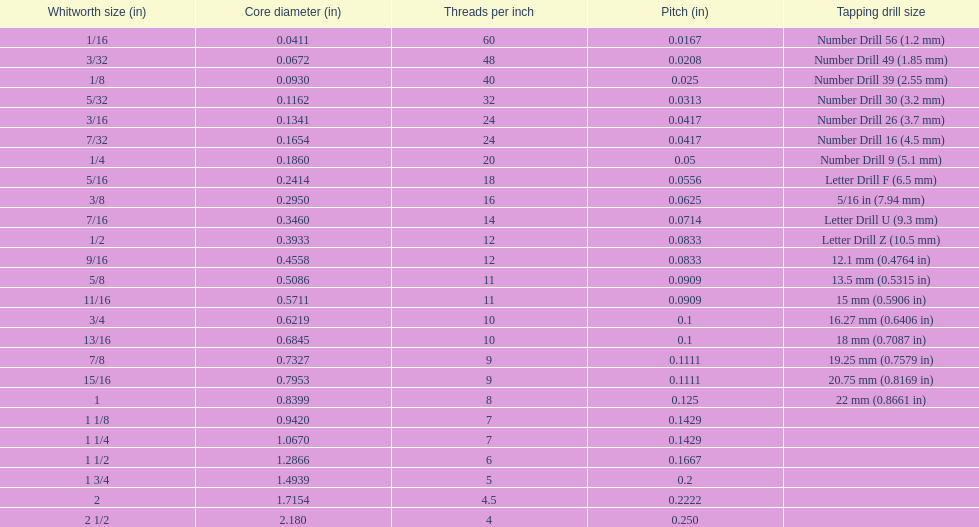Which whitworth size possesses the same number of threads for every inch as 3/16? 7/32. 